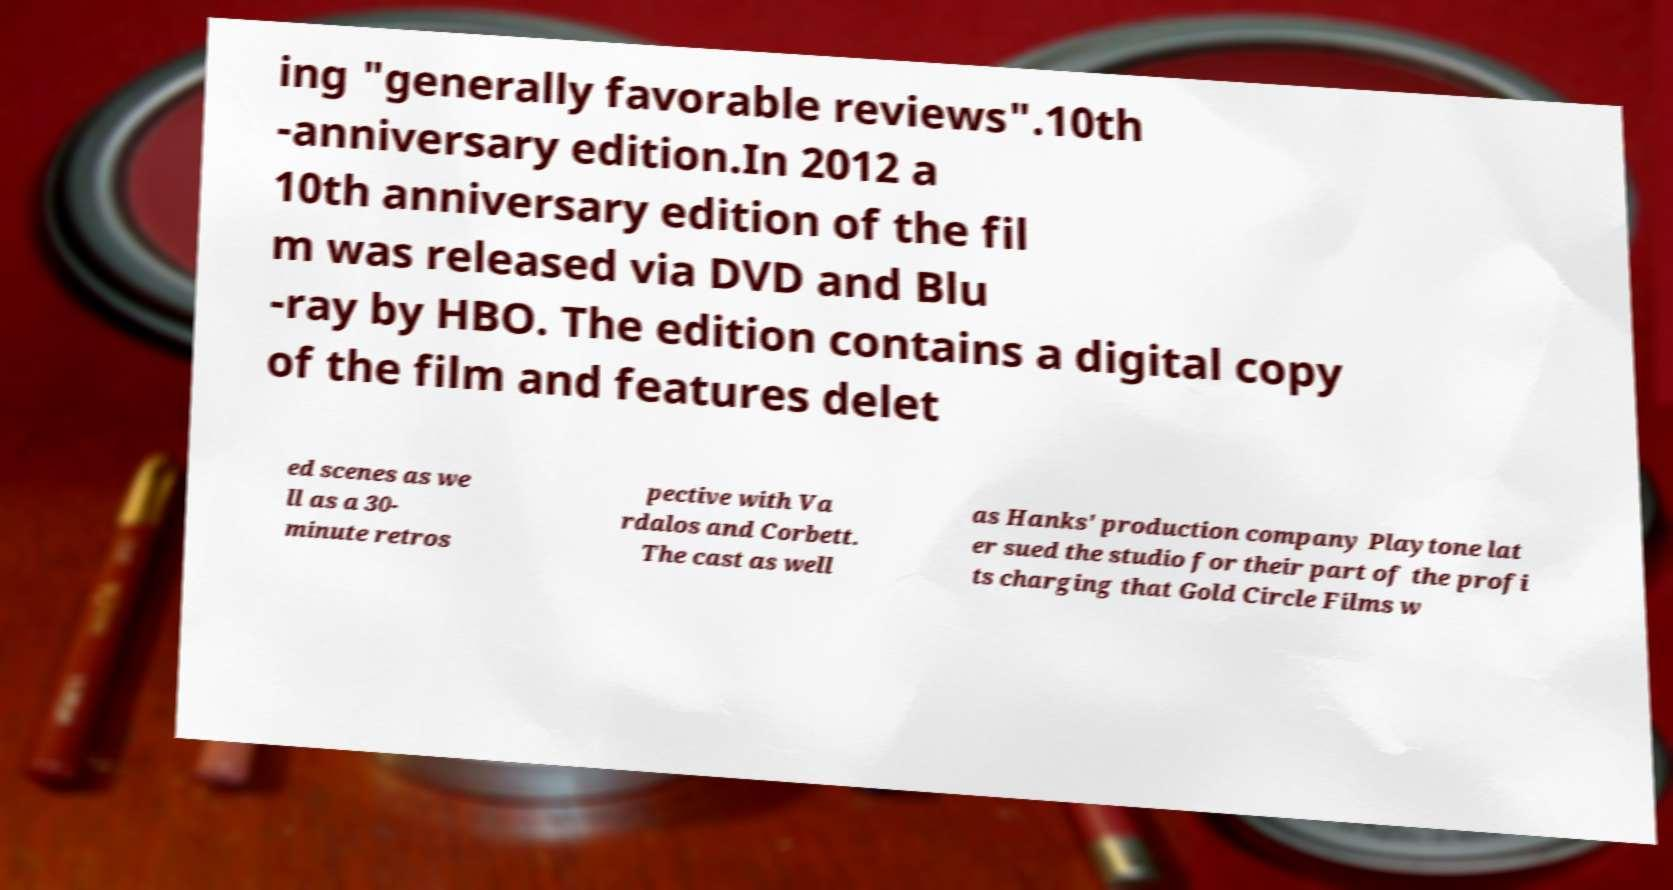Can you accurately transcribe the text from the provided image for me? ing "generally favorable reviews".10th -anniversary edition.In 2012 a 10th anniversary edition of the fil m was released via DVD and Blu -ray by HBO. The edition contains a digital copy of the film and features delet ed scenes as we ll as a 30- minute retros pective with Va rdalos and Corbett. The cast as well as Hanks' production company Playtone lat er sued the studio for their part of the profi ts charging that Gold Circle Films w 